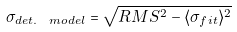<formula> <loc_0><loc_0><loc_500><loc_500>\sigma _ { d e t . \ m o d e l } = \sqrt { R M S ^ { 2 } - \langle \sigma _ { f i t } \rangle ^ { 2 } }</formula> 